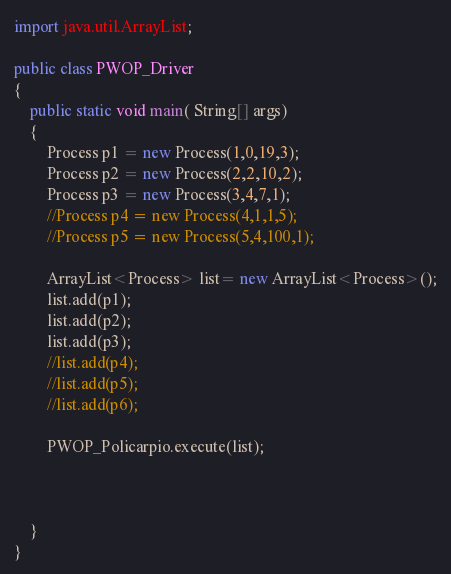<code> <loc_0><loc_0><loc_500><loc_500><_Java_>import java.util.ArrayList;

public class PWOP_Driver
{
    public static void main( String[] args)
    {
    	Process p1 = new Process(1,0,19,3);
    	Process p2 = new Process(2,2,10,2);
    	Process p3 = new Process(3,4,7,1);
    	//Process p4 = new Process(4,1,1,5);
    	//Process p5 = new Process(5,4,100,1);
    	
    	ArrayList<Process> list= new ArrayList<Process>();
    	list.add(p1);
    	list.add(p2);
    	list.add(p3);
    	//list.add(p4);
    	//list.add(p5);
    	//list.add(p6);
    	
    	PWOP_Policarpio.execute(list);
    	
    	
    
    }
}</code> 